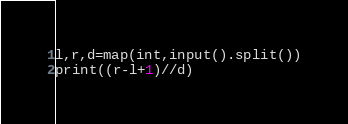Convert code to text. <code><loc_0><loc_0><loc_500><loc_500><_Python_>l,r,d=map(int,input().split())
print((r-l+1)//d)</code> 